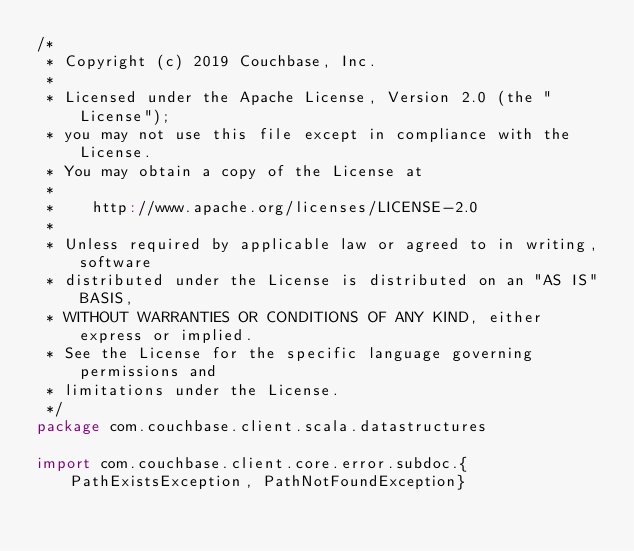<code> <loc_0><loc_0><loc_500><loc_500><_Scala_>/*
 * Copyright (c) 2019 Couchbase, Inc.
 *
 * Licensed under the Apache License, Version 2.0 (the "License");
 * you may not use this file except in compliance with the License.
 * You may obtain a copy of the License at
 *
 *    http://www.apache.org/licenses/LICENSE-2.0
 *
 * Unless required by applicable law or agreed to in writing, software
 * distributed under the License is distributed on an "AS IS" BASIS,
 * WITHOUT WARRANTIES OR CONDITIONS OF ANY KIND, either express or implied.
 * See the License for the specific language governing permissions and
 * limitations under the License.
 */
package com.couchbase.client.scala.datastructures

import com.couchbase.client.core.error.subdoc.{PathExistsException, PathNotFoundException}</code> 